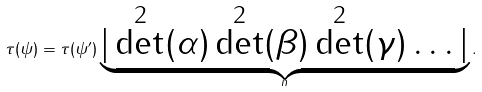Convert formula to latex. <formula><loc_0><loc_0><loc_500><loc_500>\tau ( \psi ) = \tau ( \psi ^ { \prime } ) \underbrace { | \det ^ { 2 } ( \alpha ) \det ^ { 2 } ( \beta ) \det ^ { 2 } ( \gamma ) \dots | } _ { n } .</formula> 